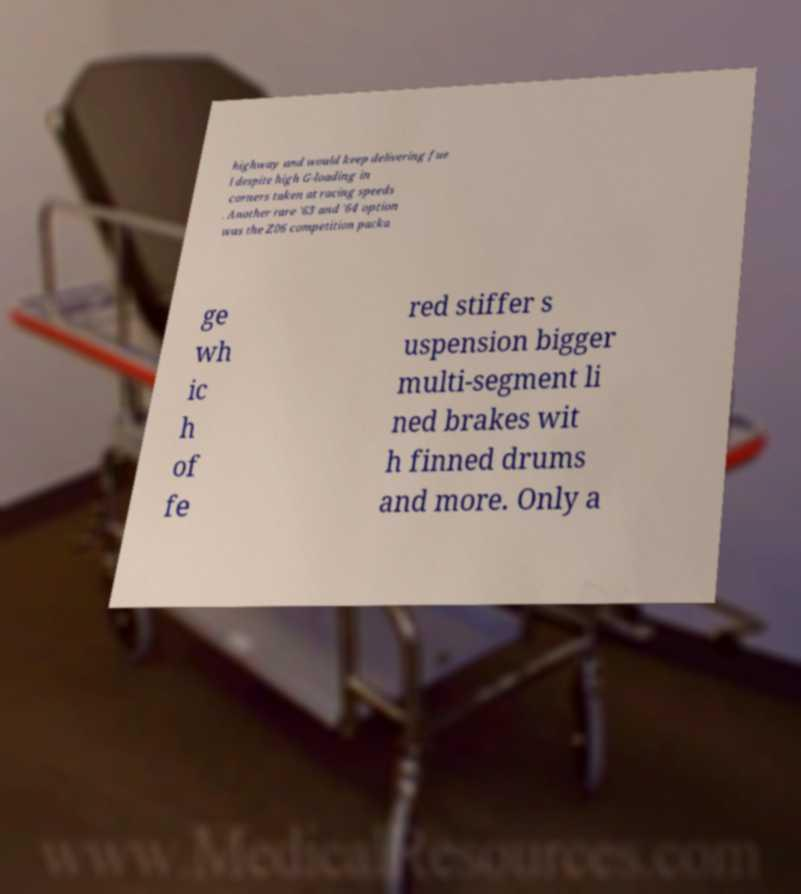Can you read and provide the text displayed in the image?This photo seems to have some interesting text. Can you extract and type it out for me? highway and would keep delivering fue l despite high G-loading in corners taken at racing speeds . Another rare '63 and '64 option was the Z06 competition packa ge wh ic h of fe red stiffer s uspension bigger multi-segment li ned brakes wit h finned drums and more. Only a 